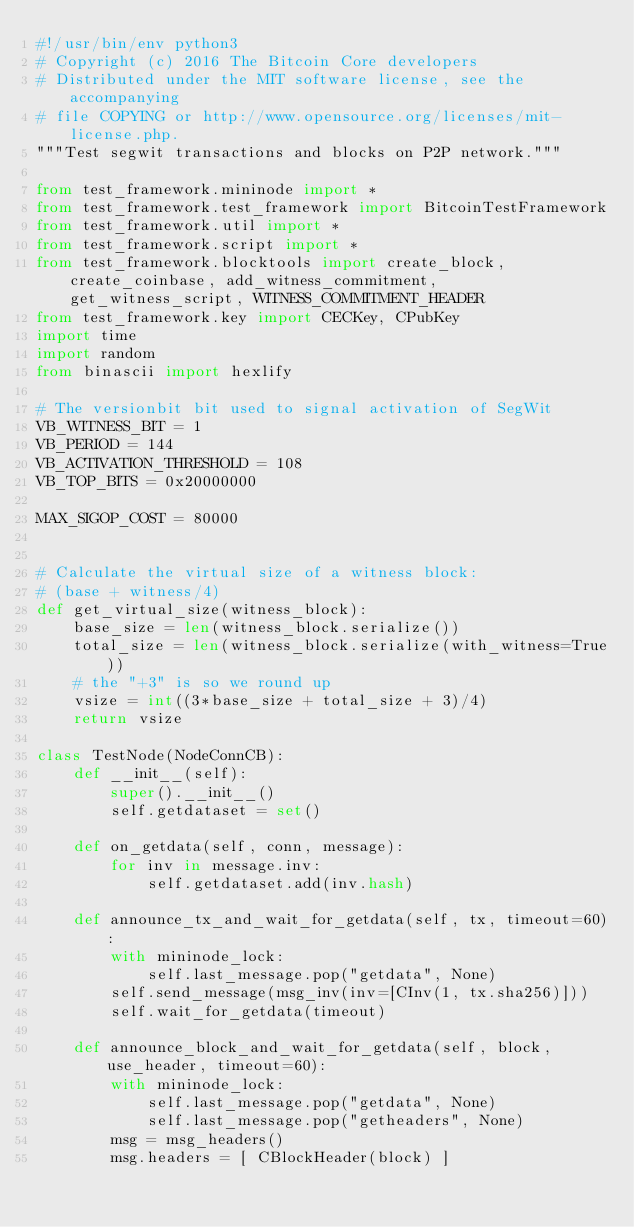<code> <loc_0><loc_0><loc_500><loc_500><_Python_>#!/usr/bin/env python3
# Copyright (c) 2016 The Bitcoin Core developers
# Distributed under the MIT software license, see the accompanying
# file COPYING or http://www.opensource.org/licenses/mit-license.php.
"""Test segwit transactions and blocks on P2P network."""

from test_framework.mininode import *
from test_framework.test_framework import BitcoinTestFramework
from test_framework.util import *
from test_framework.script import *
from test_framework.blocktools import create_block, create_coinbase, add_witness_commitment, get_witness_script, WITNESS_COMMITMENT_HEADER
from test_framework.key import CECKey, CPubKey
import time
import random
from binascii import hexlify

# The versionbit bit used to signal activation of SegWit
VB_WITNESS_BIT = 1
VB_PERIOD = 144
VB_ACTIVATION_THRESHOLD = 108
VB_TOP_BITS = 0x20000000

MAX_SIGOP_COST = 80000


# Calculate the virtual size of a witness block:
# (base + witness/4)
def get_virtual_size(witness_block):
    base_size = len(witness_block.serialize())
    total_size = len(witness_block.serialize(with_witness=True))
    # the "+3" is so we round up
    vsize = int((3*base_size + total_size + 3)/4)
    return vsize

class TestNode(NodeConnCB):
    def __init__(self):
        super().__init__()
        self.getdataset = set()

    def on_getdata(self, conn, message):
        for inv in message.inv:
            self.getdataset.add(inv.hash)

    def announce_tx_and_wait_for_getdata(self, tx, timeout=60):
        with mininode_lock:
            self.last_message.pop("getdata", None)
        self.send_message(msg_inv(inv=[CInv(1, tx.sha256)]))
        self.wait_for_getdata(timeout)

    def announce_block_and_wait_for_getdata(self, block, use_header, timeout=60):
        with mininode_lock:
            self.last_message.pop("getdata", None)
            self.last_message.pop("getheaders", None)
        msg = msg_headers()
        msg.headers = [ CBlockHeader(block) ]</code> 